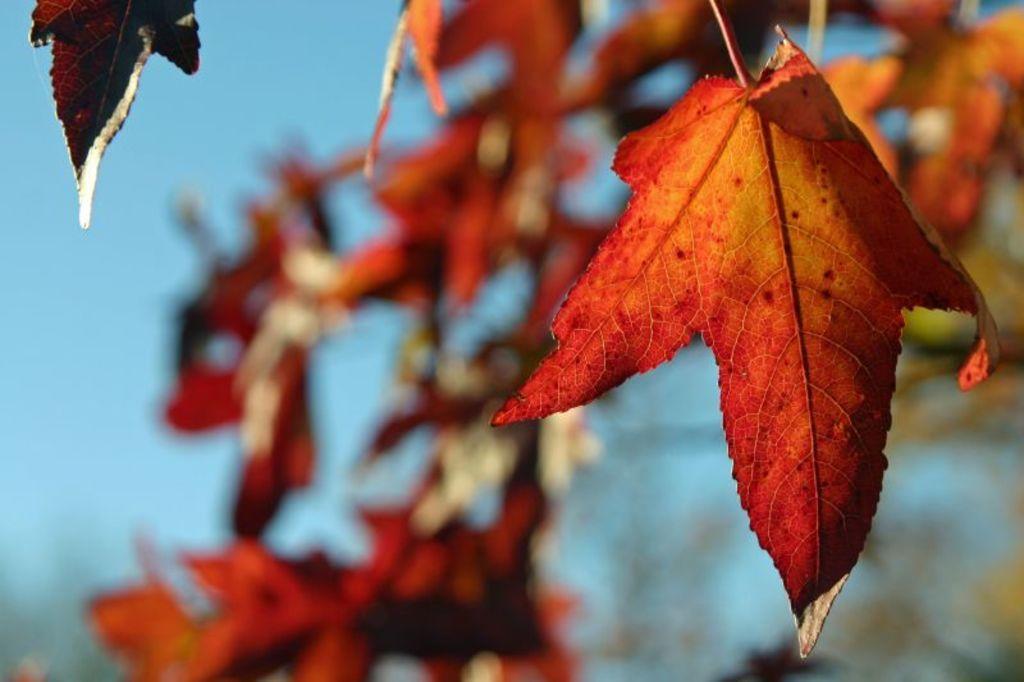In one or two sentences, can you explain what this image depicts? In the center of the image we can see one leaf, which is in red and yellow color. At the top left side of the image, we can see one more leaf. In the background, we can see it is blurred. 